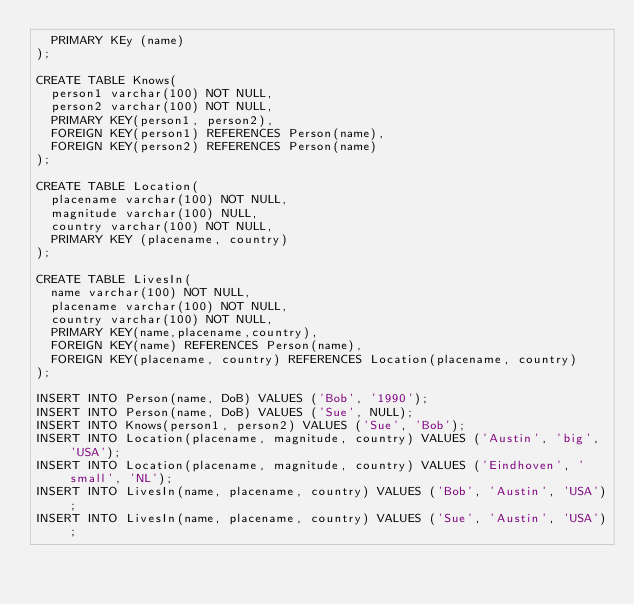<code> <loc_0><loc_0><loc_500><loc_500><_SQL_>	PRIMARY KEy (name)
);

CREATE TABLE Knows(
	person1 varchar(100) NOT NULL,
	person2 varchar(100) NOT NULL,
	PRIMARY KEY(person1, person2),
	FOREIGN KEY(person1) REFERENCES Person(name),
	FOREIGN KEY(person2) REFERENCES Person(name)
);

CREATE TABLE Location(
	placename varchar(100) NOT NULL,
	magnitude varchar(100) NULL,
	country varchar(100) NOT NULL,
	PRIMARY KEY (placename, country)
);

CREATE TABLE LivesIn(
	name varchar(100) NOT NULL,
	placename varchar(100) NOT NULL,
	country varchar(100) NOT NULL,
	PRIMARY KEY(name,placename,country),
	FOREIGN KEY(name) REFERENCES Person(name),
	FOREIGN KEY(placename, country) REFERENCES Location(placename, country)
);

INSERT INTO Person(name, DoB) VALUES ('Bob', '1990');
INSERT INTO Person(name, DoB) VALUES ('Sue', NULL);
INSERT INTO Knows(person1, person2) VALUES ('Sue', 'Bob');
INSERT INTO Location(placename, magnitude, country) VALUES ('Austin', 'big', 'USA');
INSERT INTO Location(placename, magnitude, country) VALUES ('Eindhoven', 'small', 'NL');
INSERT INTO LivesIn(name, placename, country) VALUES ('Bob', 'Austin', 'USA');
INSERT INTO LivesIn(name, placename, country) VALUES ('Sue', 'Austin', 'USA');</code> 